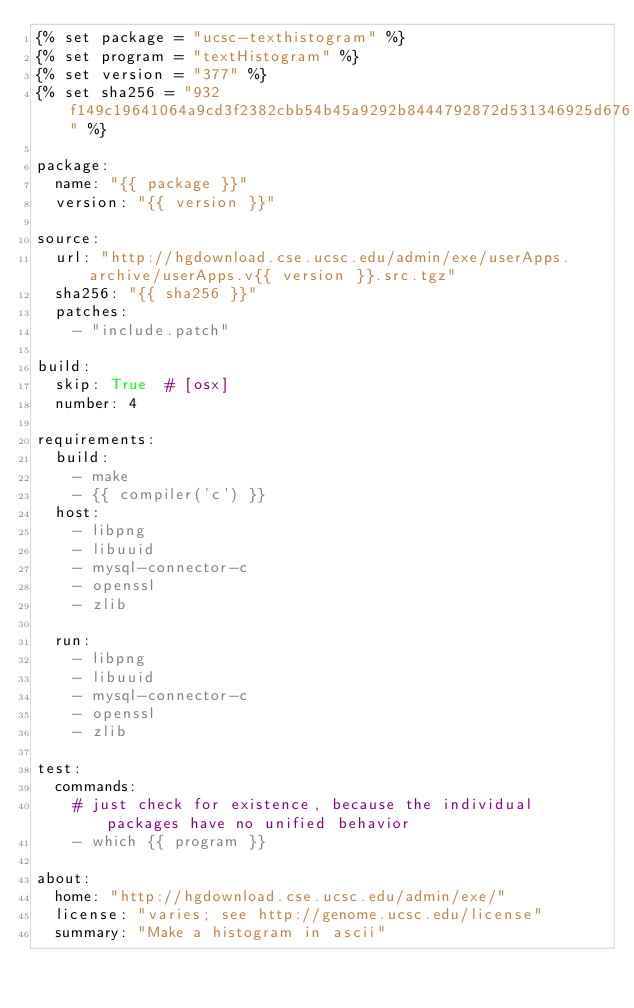Convert code to text. <code><loc_0><loc_0><loc_500><loc_500><_YAML_>{% set package = "ucsc-texthistogram" %}
{% set program = "textHistogram" %}
{% set version = "377" %}
{% set sha256 = "932f149c19641064a9cd3f2382cbb54b45a9292b8444792872d531346925d676" %}

package:
  name: "{{ package }}"
  version: "{{ version }}"

source:
  url: "http://hgdownload.cse.ucsc.edu/admin/exe/userApps.archive/userApps.v{{ version }}.src.tgz"
  sha256: "{{ sha256 }}"
  patches:
    - "include.patch"

build:
  skip: True  # [osx]
  number: 4

requirements:
  build:
    - make
    - {{ compiler('c') }}
  host:
    - libpng
    - libuuid
    - mysql-connector-c
    - openssl
    - zlib

  run:
    - libpng
    - libuuid
    - mysql-connector-c
    - openssl
    - zlib

test:
  commands:
    # just check for existence, because the individual packages have no unified behavior
    - which {{ program }}

about:
  home: "http://hgdownload.cse.ucsc.edu/admin/exe/"
  license: "varies; see http://genome.ucsc.edu/license"
  summary: "Make a histogram in ascii"
</code> 